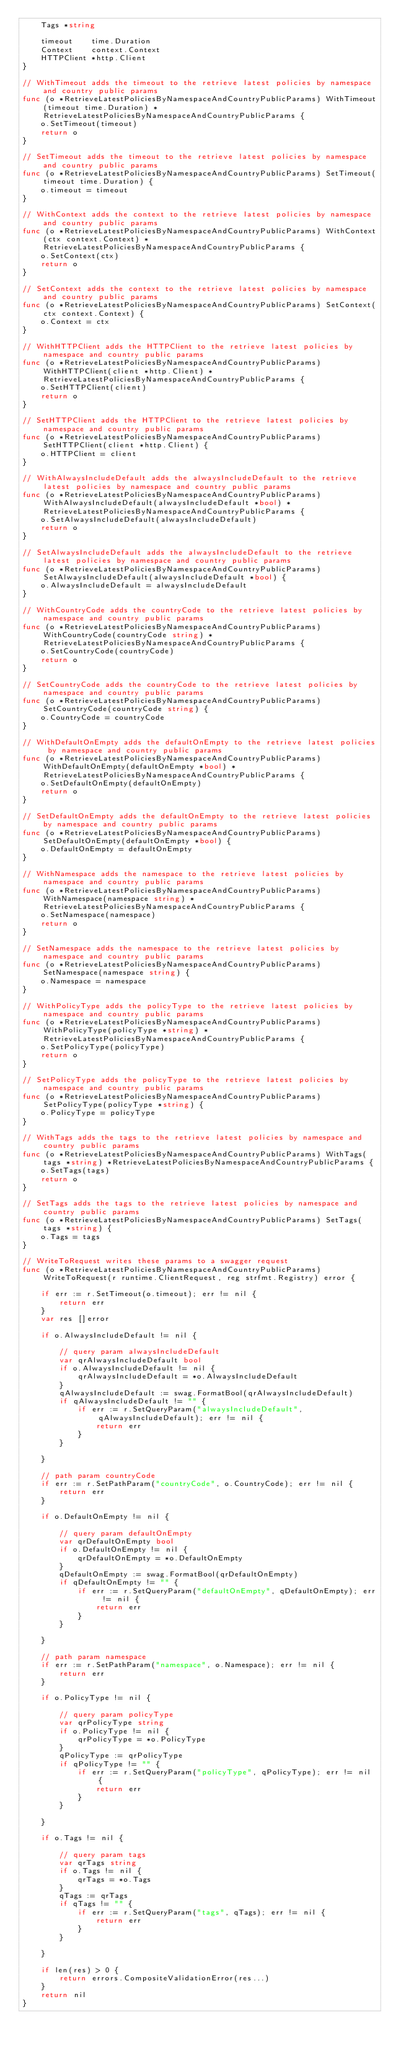<code> <loc_0><loc_0><loc_500><loc_500><_Go_>	Tags *string

	timeout    time.Duration
	Context    context.Context
	HTTPClient *http.Client
}

// WithTimeout adds the timeout to the retrieve latest policies by namespace and country public params
func (o *RetrieveLatestPoliciesByNamespaceAndCountryPublicParams) WithTimeout(timeout time.Duration) *RetrieveLatestPoliciesByNamespaceAndCountryPublicParams {
	o.SetTimeout(timeout)
	return o
}

// SetTimeout adds the timeout to the retrieve latest policies by namespace and country public params
func (o *RetrieveLatestPoliciesByNamespaceAndCountryPublicParams) SetTimeout(timeout time.Duration) {
	o.timeout = timeout
}

// WithContext adds the context to the retrieve latest policies by namespace and country public params
func (o *RetrieveLatestPoliciesByNamespaceAndCountryPublicParams) WithContext(ctx context.Context) *RetrieveLatestPoliciesByNamespaceAndCountryPublicParams {
	o.SetContext(ctx)
	return o
}

// SetContext adds the context to the retrieve latest policies by namespace and country public params
func (o *RetrieveLatestPoliciesByNamespaceAndCountryPublicParams) SetContext(ctx context.Context) {
	o.Context = ctx
}

// WithHTTPClient adds the HTTPClient to the retrieve latest policies by namespace and country public params
func (o *RetrieveLatestPoliciesByNamespaceAndCountryPublicParams) WithHTTPClient(client *http.Client) *RetrieveLatestPoliciesByNamespaceAndCountryPublicParams {
	o.SetHTTPClient(client)
	return o
}

// SetHTTPClient adds the HTTPClient to the retrieve latest policies by namespace and country public params
func (o *RetrieveLatestPoliciesByNamespaceAndCountryPublicParams) SetHTTPClient(client *http.Client) {
	o.HTTPClient = client
}

// WithAlwaysIncludeDefault adds the alwaysIncludeDefault to the retrieve latest policies by namespace and country public params
func (o *RetrieveLatestPoliciesByNamespaceAndCountryPublicParams) WithAlwaysIncludeDefault(alwaysIncludeDefault *bool) *RetrieveLatestPoliciesByNamespaceAndCountryPublicParams {
	o.SetAlwaysIncludeDefault(alwaysIncludeDefault)
	return o
}

// SetAlwaysIncludeDefault adds the alwaysIncludeDefault to the retrieve latest policies by namespace and country public params
func (o *RetrieveLatestPoliciesByNamespaceAndCountryPublicParams) SetAlwaysIncludeDefault(alwaysIncludeDefault *bool) {
	o.AlwaysIncludeDefault = alwaysIncludeDefault
}

// WithCountryCode adds the countryCode to the retrieve latest policies by namespace and country public params
func (o *RetrieveLatestPoliciesByNamespaceAndCountryPublicParams) WithCountryCode(countryCode string) *RetrieveLatestPoliciesByNamespaceAndCountryPublicParams {
	o.SetCountryCode(countryCode)
	return o
}

// SetCountryCode adds the countryCode to the retrieve latest policies by namespace and country public params
func (o *RetrieveLatestPoliciesByNamespaceAndCountryPublicParams) SetCountryCode(countryCode string) {
	o.CountryCode = countryCode
}

// WithDefaultOnEmpty adds the defaultOnEmpty to the retrieve latest policies by namespace and country public params
func (o *RetrieveLatestPoliciesByNamespaceAndCountryPublicParams) WithDefaultOnEmpty(defaultOnEmpty *bool) *RetrieveLatestPoliciesByNamespaceAndCountryPublicParams {
	o.SetDefaultOnEmpty(defaultOnEmpty)
	return o
}

// SetDefaultOnEmpty adds the defaultOnEmpty to the retrieve latest policies by namespace and country public params
func (o *RetrieveLatestPoliciesByNamespaceAndCountryPublicParams) SetDefaultOnEmpty(defaultOnEmpty *bool) {
	o.DefaultOnEmpty = defaultOnEmpty
}

// WithNamespace adds the namespace to the retrieve latest policies by namespace and country public params
func (o *RetrieveLatestPoliciesByNamespaceAndCountryPublicParams) WithNamespace(namespace string) *RetrieveLatestPoliciesByNamespaceAndCountryPublicParams {
	o.SetNamespace(namespace)
	return o
}

// SetNamespace adds the namespace to the retrieve latest policies by namespace and country public params
func (o *RetrieveLatestPoliciesByNamespaceAndCountryPublicParams) SetNamespace(namespace string) {
	o.Namespace = namespace
}

// WithPolicyType adds the policyType to the retrieve latest policies by namespace and country public params
func (o *RetrieveLatestPoliciesByNamespaceAndCountryPublicParams) WithPolicyType(policyType *string) *RetrieveLatestPoliciesByNamespaceAndCountryPublicParams {
	o.SetPolicyType(policyType)
	return o
}

// SetPolicyType adds the policyType to the retrieve latest policies by namespace and country public params
func (o *RetrieveLatestPoliciesByNamespaceAndCountryPublicParams) SetPolicyType(policyType *string) {
	o.PolicyType = policyType
}

// WithTags adds the tags to the retrieve latest policies by namespace and country public params
func (o *RetrieveLatestPoliciesByNamespaceAndCountryPublicParams) WithTags(tags *string) *RetrieveLatestPoliciesByNamespaceAndCountryPublicParams {
	o.SetTags(tags)
	return o
}

// SetTags adds the tags to the retrieve latest policies by namespace and country public params
func (o *RetrieveLatestPoliciesByNamespaceAndCountryPublicParams) SetTags(tags *string) {
	o.Tags = tags
}

// WriteToRequest writes these params to a swagger request
func (o *RetrieveLatestPoliciesByNamespaceAndCountryPublicParams) WriteToRequest(r runtime.ClientRequest, reg strfmt.Registry) error {

	if err := r.SetTimeout(o.timeout); err != nil {
		return err
	}
	var res []error

	if o.AlwaysIncludeDefault != nil {

		// query param alwaysIncludeDefault
		var qrAlwaysIncludeDefault bool
		if o.AlwaysIncludeDefault != nil {
			qrAlwaysIncludeDefault = *o.AlwaysIncludeDefault
		}
		qAlwaysIncludeDefault := swag.FormatBool(qrAlwaysIncludeDefault)
		if qAlwaysIncludeDefault != "" {
			if err := r.SetQueryParam("alwaysIncludeDefault", qAlwaysIncludeDefault); err != nil {
				return err
			}
		}

	}

	// path param countryCode
	if err := r.SetPathParam("countryCode", o.CountryCode); err != nil {
		return err
	}

	if o.DefaultOnEmpty != nil {

		// query param defaultOnEmpty
		var qrDefaultOnEmpty bool
		if o.DefaultOnEmpty != nil {
			qrDefaultOnEmpty = *o.DefaultOnEmpty
		}
		qDefaultOnEmpty := swag.FormatBool(qrDefaultOnEmpty)
		if qDefaultOnEmpty != "" {
			if err := r.SetQueryParam("defaultOnEmpty", qDefaultOnEmpty); err != nil {
				return err
			}
		}

	}

	// path param namespace
	if err := r.SetPathParam("namespace", o.Namespace); err != nil {
		return err
	}

	if o.PolicyType != nil {

		// query param policyType
		var qrPolicyType string
		if o.PolicyType != nil {
			qrPolicyType = *o.PolicyType
		}
		qPolicyType := qrPolicyType
		if qPolicyType != "" {
			if err := r.SetQueryParam("policyType", qPolicyType); err != nil {
				return err
			}
		}

	}

	if o.Tags != nil {

		// query param tags
		var qrTags string
		if o.Tags != nil {
			qrTags = *o.Tags
		}
		qTags := qrTags
		if qTags != "" {
			if err := r.SetQueryParam("tags", qTags); err != nil {
				return err
			}
		}

	}

	if len(res) > 0 {
		return errors.CompositeValidationError(res...)
	}
	return nil
}
</code> 